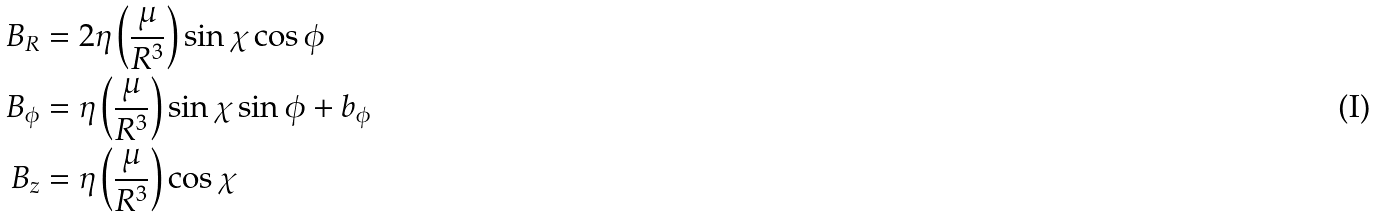<formula> <loc_0><loc_0><loc_500><loc_500>B _ { R } & = 2 \eta \left ( \frac { \mu } { R ^ { 3 } } \right ) \sin \chi \cos \phi \\ B _ { \phi } & = \eta \left ( \frac { \mu } { R ^ { 3 } } \right ) \sin \chi \sin \phi + b _ { \phi } \\ B _ { z } & = \eta \left ( \frac { \mu } { R ^ { 3 } } \right ) \cos \chi</formula> 